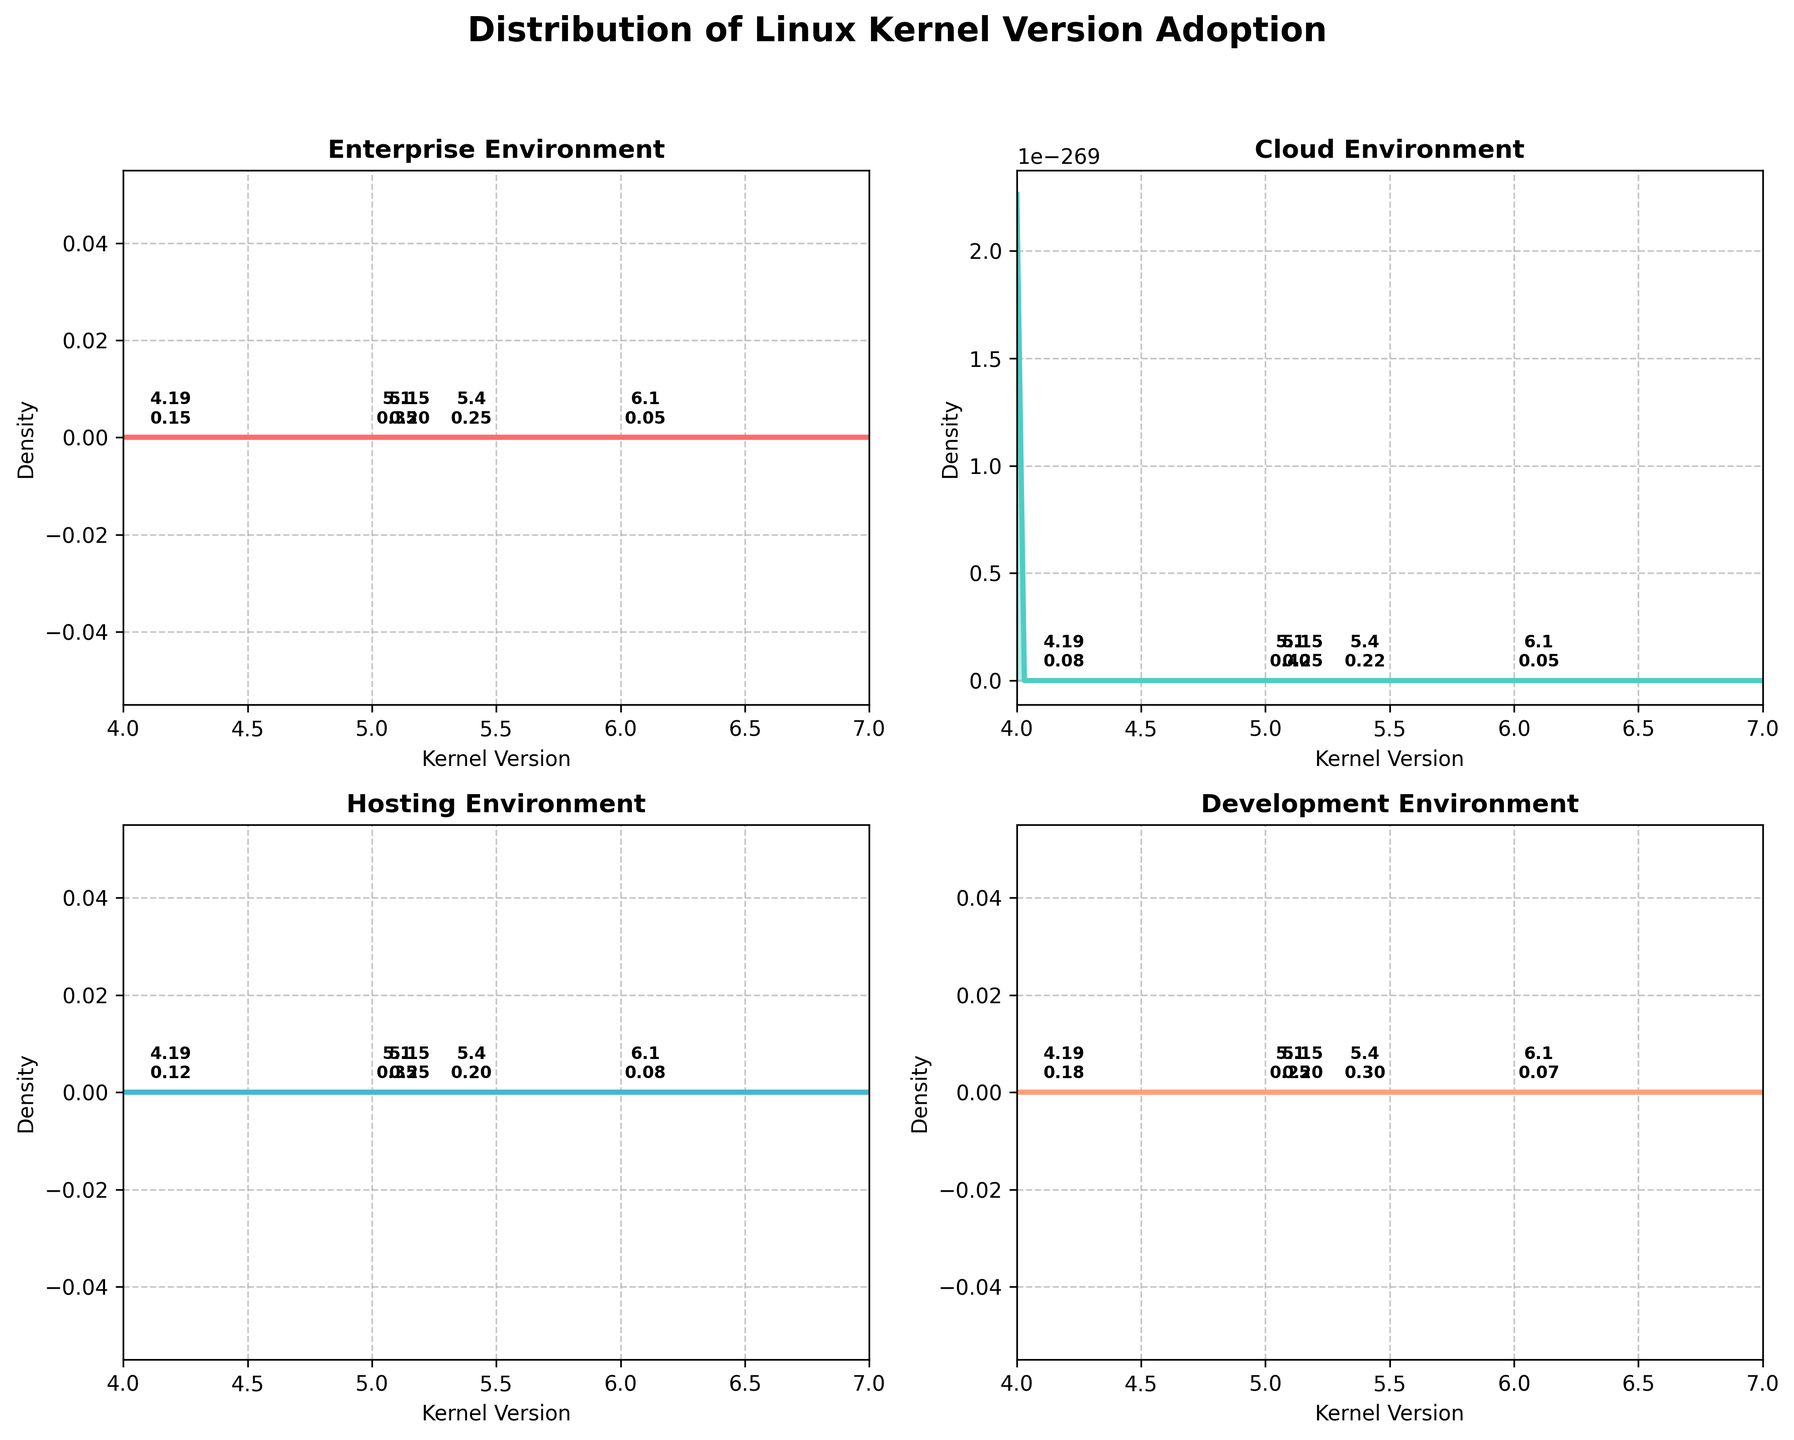What is the title of the figure? The title of the figure is written at the top and reads "Distribution of Linux Kernel Version Adoption".
Answer: Distribution of Linux Kernel Version Adoption Which environment has the highest density at kernel version 5.4? By looking at the plots, we can observe that in the "development" environment, the density at kernel version 5.4 is the highest compared to others.
Answer: development What is the kernel version with the lowest adoption density in the enterprise environment? In the enterprise environment plot, the density for kernel version 6.1 is the lowest as compared to other kernel versions.
Answer: 6.1 Which two environments show an equal density for kernel version 4.19? Comparing the densities for kernel version 4.19, we can see that both "cloud" and "hosting" environments exhibit a density of 0.08.
Answer: cloud, hosting How does the density of kernel version 5.10 in the cloud environment compare to that in the enterprise environment? In the plots, the density for kernel version 5.10 in the cloud environment is higher than in the enterprise environment.
Answer: higher What kernel version has the most uniform adoption across all server environments? By examining the plots, kernel version 5.15 seems to have similar density values across all four environments, indicating it is the most uniformly adopted.
Answer: 5.15 What's the difference in density at kernel version 5.4 between the hosting and development environments? In the hosting environment, the density at kernel version 5.4 is 0.20, and in the development environment, it is 0.30. The difference is 0.30 - 0.20 = 0.10.
Answer: 0.10 Which environment has the most varied adoption across different kernel versions? The development environment shows the most varied adoption as the density values change more significantly compared to other environments.
Answer: development 